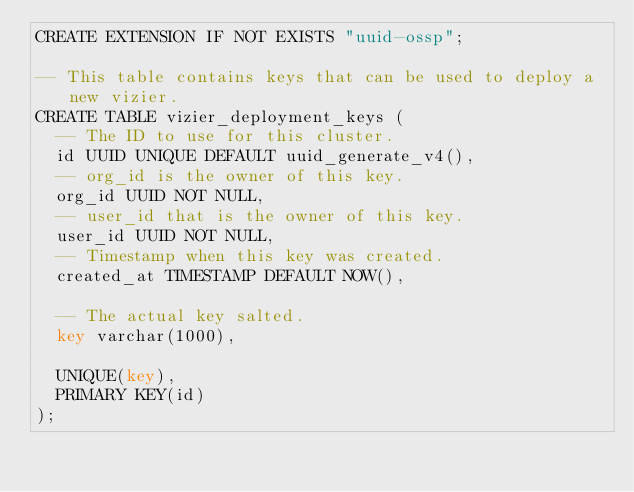<code> <loc_0><loc_0><loc_500><loc_500><_SQL_>CREATE EXTENSION IF NOT EXISTS "uuid-ossp";

-- This table contains keys that can be used to deploy a new vizier.
CREATE TABLE vizier_deployment_keys (
  -- The ID to use for this cluster.
  id UUID UNIQUE DEFAULT uuid_generate_v4(),
  -- org_id is the owner of this key.
  org_id UUID NOT NULL,
  -- user_id that is the owner of this key.
  user_id UUID NOT NULL,
  -- Timestamp when this key was created.
  created_at TIMESTAMP DEFAULT NOW(),

  -- The actual key salted.
  key varchar(1000),

  UNIQUE(key),
  PRIMARY KEY(id)
);
</code> 